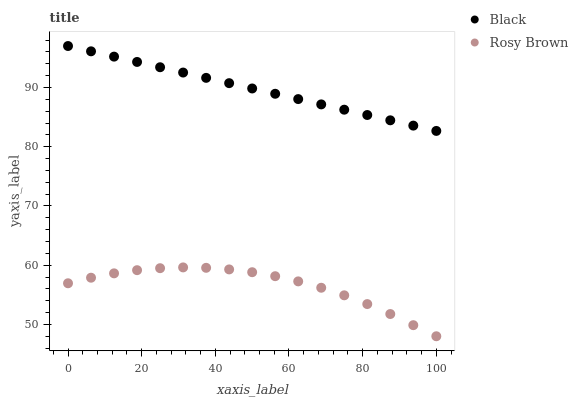Does Rosy Brown have the minimum area under the curve?
Answer yes or no. Yes. Does Black have the maximum area under the curve?
Answer yes or no. Yes. Does Black have the minimum area under the curve?
Answer yes or no. No. Is Black the smoothest?
Answer yes or no. Yes. Is Rosy Brown the roughest?
Answer yes or no. Yes. Is Black the roughest?
Answer yes or no. No. Does Rosy Brown have the lowest value?
Answer yes or no. Yes. Does Black have the lowest value?
Answer yes or no. No. Does Black have the highest value?
Answer yes or no. Yes. Is Rosy Brown less than Black?
Answer yes or no. Yes. Is Black greater than Rosy Brown?
Answer yes or no. Yes. Does Rosy Brown intersect Black?
Answer yes or no. No. 